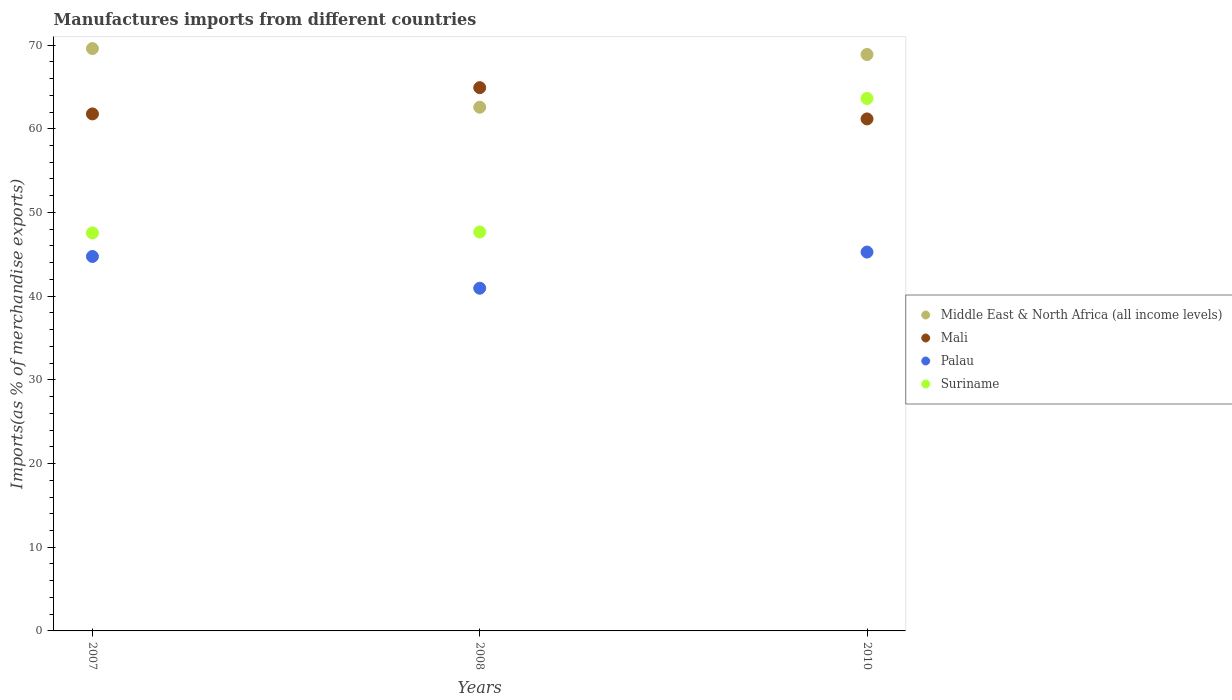What is the percentage of imports to different countries in Suriname in 2010?
Keep it short and to the point. 63.62. Across all years, what is the maximum percentage of imports to different countries in Middle East & North Africa (all income levels)?
Provide a short and direct response. 69.58. Across all years, what is the minimum percentage of imports to different countries in Middle East & North Africa (all income levels)?
Your response must be concise. 62.57. In which year was the percentage of imports to different countries in Middle East & North Africa (all income levels) minimum?
Keep it short and to the point. 2008. What is the total percentage of imports to different countries in Suriname in the graph?
Keep it short and to the point. 158.84. What is the difference between the percentage of imports to different countries in Palau in 2007 and that in 2010?
Your response must be concise. -0.53. What is the difference between the percentage of imports to different countries in Middle East & North Africa (all income levels) in 2008 and the percentage of imports to different countries in Palau in 2010?
Keep it short and to the point. 17.31. What is the average percentage of imports to different countries in Middle East & North Africa (all income levels) per year?
Make the answer very short. 67.01. In the year 2008, what is the difference between the percentage of imports to different countries in Palau and percentage of imports to different countries in Middle East & North Africa (all income levels)?
Provide a succinct answer. -21.63. In how many years, is the percentage of imports to different countries in Palau greater than 52 %?
Provide a short and direct response. 0. What is the ratio of the percentage of imports to different countries in Middle East & North Africa (all income levels) in 2007 to that in 2008?
Give a very brief answer. 1.11. Is the difference between the percentage of imports to different countries in Palau in 2007 and 2010 greater than the difference between the percentage of imports to different countries in Middle East & North Africa (all income levels) in 2007 and 2010?
Offer a very short reply. No. What is the difference between the highest and the second highest percentage of imports to different countries in Middle East & North Africa (all income levels)?
Your response must be concise. 0.71. What is the difference between the highest and the lowest percentage of imports to different countries in Middle East & North Africa (all income levels)?
Provide a short and direct response. 7.01. Is it the case that in every year, the sum of the percentage of imports to different countries in Palau and percentage of imports to different countries in Mali  is greater than the sum of percentage of imports to different countries in Suriname and percentage of imports to different countries in Middle East & North Africa (all income levels)?
Your response must be concise. No. Is it the case that in every year, the sum of the percentage of imports to different countries in Mali and percentage of imports to different countries in Palau  is greater than the percentage of imports to different countries in Suriname?
Give a very brief answer. Yes. Is the percentage of imports to different countries in Mali strictly greater than the percentage of imports to different countries in Palau over the years?
Offer a very short reply. Yes. Are the values on the major ticks of Y-axis written in scientific E-notation?
Provide a succinct answer. No. Does the graph contain grids?
Your answer should be very brief. No. What is the title of the graph?
Your response must be concise. Manufactures imports from different countries. What is the label or title of the Y-axis?
Offer a terse response. Imports(as % of merchandise exports). What is the Imports(as % of merchandise exports) in Middle East & North Africa (all income levels) in 2007?
Give a very brief answer. 69.58. What is the Imports(as % of merchandise exports) in Mali in 2007?
Make the answer very short. 61.77. What is the Imports(as % of merchandise exports) in Palau in 2007?
Ensure brevity in your answer.  44.74. What is the Imports(as % of merchandise exports) of Suriname in 2007?
Make the answer very short. 47.55. What is the Imports(as % of merchandise exports) in Middle East & North Africa (all income levels) in 2008?
Ensure brevity in your answer.  62.57. What is the Imports(as % of merchandise exports) of Mali in 2008?
Your answer should be very brief. 64.91. What is the Imports(as % of merchandise exports) of Palau in 2008?
Offer a terse response. 40.95. What is the Imports(as % of merchandise exports) in Suriname in 2008?
Make the answer very short. 47.67. What is the Imports(as % of merchandise exports) of Middle East & North Africa (all income levels) in 2010?
Make the answer very short. 68.87. What is the Imports(as % of merchandise exports) in Mali in 2010?
Ensure brevity in your answer.  61.17. What is the Imports(as % of merchandise exports) in Palau in 2010?
Provide a succinct answer. 45.27. What is the Imports(as % of merchandise exports) in Suriname in 2010?
Your response must be concise. 63.62. Across all years, what is the maximum Imports(as % of merchandise exports) in Middle East & North Africa (all income levels)?
Provide a succinct answer. 69.58. Across all years, what is the maximum Imports(as % of merchandise exports) in Mali?
Your response must be concise. 64.91. Across all years, what is the maximum Imports(as % of merchandise exports) of Palau?
Ensure brevity in your answer.  45.27. Across all years, what is the maximum Imports(as % of merchandise exports) in Suriname?
Make the answer very short. 63.62. Across all years, what is the minimum Imports(as % of merchandise exports) of Middle East & North Africa (all income levels)?
Keep it short and to the point. 62.57. Across all years, what is the minimum Imports(as % of merchandise exports) of Mali?
Your response must be concise. 61.17. Across all years, what is the minimum Imports(as % of merchandise exports) of Palau?
Ensure brevity in your answer.  40.95. Across all years, what is the minimum Imports(as % of merchandise exports) of Suriname?
Provide a short and direct response. 47.55. What is the total Imports(as % of merchandise exports) of Middle East & North Africa (all income levels) in the graph?
Ensure brevity in your answer.  201.03. What is the total Imports(as % of merchandise exports) in Mali in the graph?
Provide a succinct answer. 187.86. What is the total Imports(as % of merchandise exports) in Palau in the graph?
Ensure brevity in your answer.  130.95. What is the total Imports(as % of merchandise exports) of Suriname in the graph?
Ensure brevity in your answer.  158.84. What is the difference between the Imports(as % of merchandise exports) in Middle East & North Africa (all income levels) in 2007 and that in 2008?
Keep it short and to the point. 7.01. What is the difference between the Imports(as % of merchandise exports) of Mali in 2007 and that in 2008?
Keep it short and to the point. -3.14. What is the difference between the Imports(as % of merchandise exports) of Palau in 2007 and that in 2008?
Provide a short and direct response. 3.79. What is the difference between the Imports(as % of merchandise exports) in Suriname in 2007 and that in 2008?
Make the answer very short. -0.11. What is the difference between the Imports(as % of merchandise exports) of Middle East & North Africa (all income levels) in 2007 and that in 2010?
Offer a terse response. 0.71. What is the difference between the Imports(as % of merchandise exports) in Mali in 2007 and that in 2010?
Offer a very short reply. 0.6. What is the difference between the Imports(as % of merchandise exports) in Palau in 2007 and that in 2010?
Your answer should be very brief. -0.53. What is the difference between the Imports(as % of merchandise exports) in Suriname in 2007 and that in 2010?
Provide a succinct answer. -16.07. What is the difference between the Imports(as % of merchandise exports) of Middle East & North Africa (all income levels) in 2008 and that in 2010?
Ensure brevity in your answer.  -6.3. What is the difference between the Imports(as % of merchandise exports) of Mali in 2008 and that in 2010?
Your response must be concise. 3.74. What is the difference between the Imports(as % of merchandise exports) of Palau in 2008 and that in 2010?
Offer a very short reply. -4.32. What is the difference between the Imports(as % of merchandise exports) in Suriname in 2008 and that in 2010?
Provide a short and direct response. -15.96. What is the difference between the Imports(as % of merchandise exports) in Middle East & North Africa (all income levels) in 2007 and the Imports(as % of merchandise exports) in Mali in 2008?
Keep it short and to the point. 4.67. What is the difference between the Imports(as % of merchandise exports) of Middle East & North Africa (all income levels) in 2007 and the Imports(as % of merchandise exports) of Palau in 2008?
Provide a short and direct response. 28.64. What is the difference between the Imports(as % of merchandise exports) in Middle East & North Africa (all income levels) in 2007 and the Imports(as % of merchandise exports) in Suriname in 2008?
Your response must be concise. 21.92. What is the difference between the Imports(as % of merchandise exports) in Mali in 2007 and the Imports(as % of merchandise exports) in Palau in 2008?
Provide a short and direct response. 20.83. What is the difference between the Imports(as % of merchandise exports) in Mali in 2007 and the Imports(as % of merchandise exports) in Suriname in 2008?
Your response must be concise. 14.11. What is the difference between the Imports(as % of merchandise exports) of Palau in 2007 and the Imports(as % of merchandise exports) of Suriname in 2008?
Ensure brevity in your answer.  -2.92. What is the difference between the Imports(as % of merchandise exports) in Middle East & North Africa (all income levels) in 2007 and the Imports(as % of merchandise exports) in Mali in 2010?
Ensure brevity in your answer.  8.41. What is the difference between the Imports(as % of merchandise exports) in Middle East & North Africa (all income levels) in 2007 and the Imports(as % of merchandise exports) in Palau in 2010?
Keep it short and to the point. 24.32. What is the difference between the Imports(as % of merchandise exports) in Middle East & North Africa (all income levels) in 2007 and the Imports(as % of merchandise exports) in Suriname in 2010?
Provide a short and direct response. 5.96. What is the difference between the Imports(as % of merchandise exports) in Mali in 2007 and the Imports(as % of merchandise exports) in Palau in 2010?
Your answer should be compact. 16.51. What is the difference between the Imports(as % of merchandise exports) in Mali in 2007 and the Imports(as % of merchandise exports) in Suriname in 2010?
Your answer should be compact. -1.85. What is the difference between the Imports(as % of merchandise exports) of Palau in 2007 and the Imports(as % of merchandise exports) of Suriname in 2010?
Your answer should be very brief. -18.88. What is the difference between the Imports(as % of merchandise exports) in Middle East & North Africa (all income levels) in 2008 and the Imports(as % of merchandise exports) in Mali in 2010?
Offer a terse response. 1.4. What is the difference between the Imports(as % of merchandise exports) of Middle East & North Africa (all income levels) in 2008 and the Imports(as % of merchandise exports) of Palau in 2010?
Offer a terse response. 17.31. What is the difference between the Imports(as % of merchandise exports) of Middle East & North Africa (all income levels) in 2008 and the Imports(as % of merchandise exports) of Suriname in 2010?
Offer a terse response. -1.05. What is the difference between the Imports(as % of merchandise exports) of Mali in 2008 and the Imports(as % of merchandise exports) of Palau in 2010?
Give a very brief answer. 19.64. What is the difference between the Imports(as % of merchandise exports) in Mali in 2008 and the Imports(as % of merchandise exports) in Suriname in 2010?
Your answer should be very brief. 1.29. What is the difference between the Imports(as % of merchandise exports) in Palau in 2008 and the Imports(as % of merchandise exports) in Suriname in 2010?
Your answer should be compact. -22.67. What is the average Imports(as % of merchandise exports) in Middle East & North Africa (all income levels) per year?
Make the answer very short. 67.01. What is the average Imports(as % of merchandise exports) of Mali per year?
Keep it short and to the point. 62.62. What is the average Imports(as % of merchandise exports) of Palau per year?
Offer a very short reply. 43.65. What is the average Imports(as % of merchandise exports) of Suriname per year?
Offer a terse response. 52.95. In the year 2007, what is the difference between the Imports(as % of merchandise exports) in Middle East & North Africa (all income levels) and Imports(as % of merchandise exports) in Mali?
Offer a very short reply. 7.81. In the year 2007, what is the difference between the Imports(as % of merchandise exports) in Middle East & North Africa (all income levels) and Imports(as % of merchandise exports) in Palau?
Your response must be concise. 24.84. In the year 2007, what is the difference between the Imports(as % of merchandise exports) of Middle East & North Africa (all income levels) and Imports(as % of merchandise exports) of Suriname?
Provide a succinct answer. 22.03. In the year 2007, what is the difference between the Imports(as % of merchandise exports) of Mali and Imports(as % of merchandise exports) of Palau?
Keep it short and to the point. 17.03. In the year 2007, what is the difference between the Imports(as % of merchandise exports) of Mali and Imports(as % of merchandise exports) of Suriname?
Your response must be concise. 14.22. In the year 2007, what is the difference between the Imports(as % of merchandise exports) of Palau and Imports(as % of merchandise exports) of Suriname?
Your answer should be very brief. -2.81. In the year 2008, what is the difference between the Imports(as % of merchandise exports) in Middle East & North Africa (all income levels) and Imports(as % of merchandise exports) in Mali?
Keep it short and to the point. -2.34. In the year 2008, what is the difference between the Imports(as % of merchandise exports) of Middle East & North Africa (all income levels) and Imports(as % of merchandise exports) of Palau?
Your answer should be compact. 21.63. In the year 2008, what is the difference between the Imports(as % of merchandise exports) in Middle East & North Africa (all income levels) and Imports(as % of merchandise exports) in Suriname?
Give a very brief answer. 14.91. In the year 2008, what is the difference between the Imports(as % of merchandise exports) of Mali and Imports(as % of merchandise exports) of Palau?
Make the answer very short. 23.96. In the year 2008, what is the difference between the Imports(as % of merchandise exports) of Mali and Imports(as % of merchandise exports) of Suriname?
Provide a succinct answer. 17.25. In the year 2008, what is the difference between the Imports(as % of merchandise exports) in Palau and Imports(as % of merchandise exports) in Suriname?
Ensure brevity in your answer.  -6.72. In the year 2010, what is the difference between the Imports(as % of merchandise exports) in Middle East & North Africa (all income levels) and Imports(as % of merchandise exports) in Mali?
Provide a succinct answer. 7.7. In the year 2010, what is the difference between the Imports(as % of merchandise exports) in Middle East & North Africa (all income levels) and Imports(as % of merchandise exports) in Palau?
Keep it short and to the point. 23.61. In the year 2010, what is the difference between the Imports(as % of merchandise exports) in Middle East & North Africa (all income levels) and Imports(as % of merchandise exports) in Suriname?
Provide a short and direct response. 5.25. In the year 2010, what is the difference between the Imports(as % of merchandise exports) of Mali and Imports(as % of merchandise exports) of Palau?
Keep it short and to the point. 15.91. In the year 2010, what is the difference between the Imports(as % of merchandise exports) in Mali and Imports(as % of merchandise exports) in Suriname?
Your answer should be very brief. -2.45. In the year 2010, what is the difference between the Imports(as % of merchandise exports) of Palau and Imports(as % of merchandise exports) of Suriname?
Provide a succinct answer. -18.35. What is the ratio of the Imports(as % of merchandise exports) of Middle East & North Africa (all income levels) in 2007 to that in 2008?
Offer a terse response. 1.11. What is the ratio of the Imports(as % of merchandise exports) in Mali in 2007 to that in 2008?
Give a very brief answer. 0.95. What is the ratio of the Imports(as % of merchandise exports) of Palau in 2007 to that in 2008?
Your response must be concise. 1.09. What is the ratio of the Imports(as % of merchandise exports) of Middle East & North Africa (all income levels) in 2007 to that in 2010?
Keep it short and to the point. 1.01. What is the ratio of the Imports(as % of merchandise exports) in Mali in 2007 to that in 2010?
Make the answer very short. 1.01. What is the ratio of the Imports(as % of merchandise exports) in Palau in 2007 to that in 2010?
Offer a very short reply. 0.99. What is the ratio of the Imports(as % of merchandise exports) in Suriname in 2007 to that in 2010?
Provide a short and direct response. 0.75. What is the ratio of the Imports(as % of merchandise exports) in Middle East & North Africa (all income levels) in 2008 to that in 2010?
Provide a short and direct response. 0.91. What is the ratio of the Imports(as % of merchandise exports) of Mali in 2008 to that in 2010?
Offer a terse response. 1.06. What is the ratio of the Imports(as % of merchandise exports) in Palau in 2008 to that in 2010?
Provide a succinct answer. 0.9. What is the ratio of the Imports(as % of merchandise exports) in Suriname in 2008 to that in 2010?
Ensure brevity in your answer.  0.75. What is the difference between the highest and the second highest Imports(as % of merchandise exports) in Middle East & North Africa (all income levels)?
Provide a short and direct response. 0.71. What is the difference between the highest and the second highest Imports(as % of merchandise exports) of Mali?
Make the answer very short. 3.14. What is the difference between the highest and the second highest Imports(as % of merchandise exports) in Palau?
Your answer should be compact. 0.53. What is the difference between the highest and the second highest Imports(as % of merchandise exports) in Suriname?
Your answer should be very brief. 15.96. What is the difference between the highest and the lowest Imports(as % of merchandise exports) of Middle East & North Africa (all income levels)?
Offer a terse response. 7.01. What is the difference between the highest and the lowest Imports(as % of merchandise exports) in Mali?
Offer a very short reply. 3.74. What is the difference between the highest and the lowest Imports(as % of merchandise exports) of Palau?
Provide a succinct answer. 4.32. What is the difference between the highest and the lowest Imports(as % of merchandise exports) in Suriname?
Make the answer very short. 16.07. 